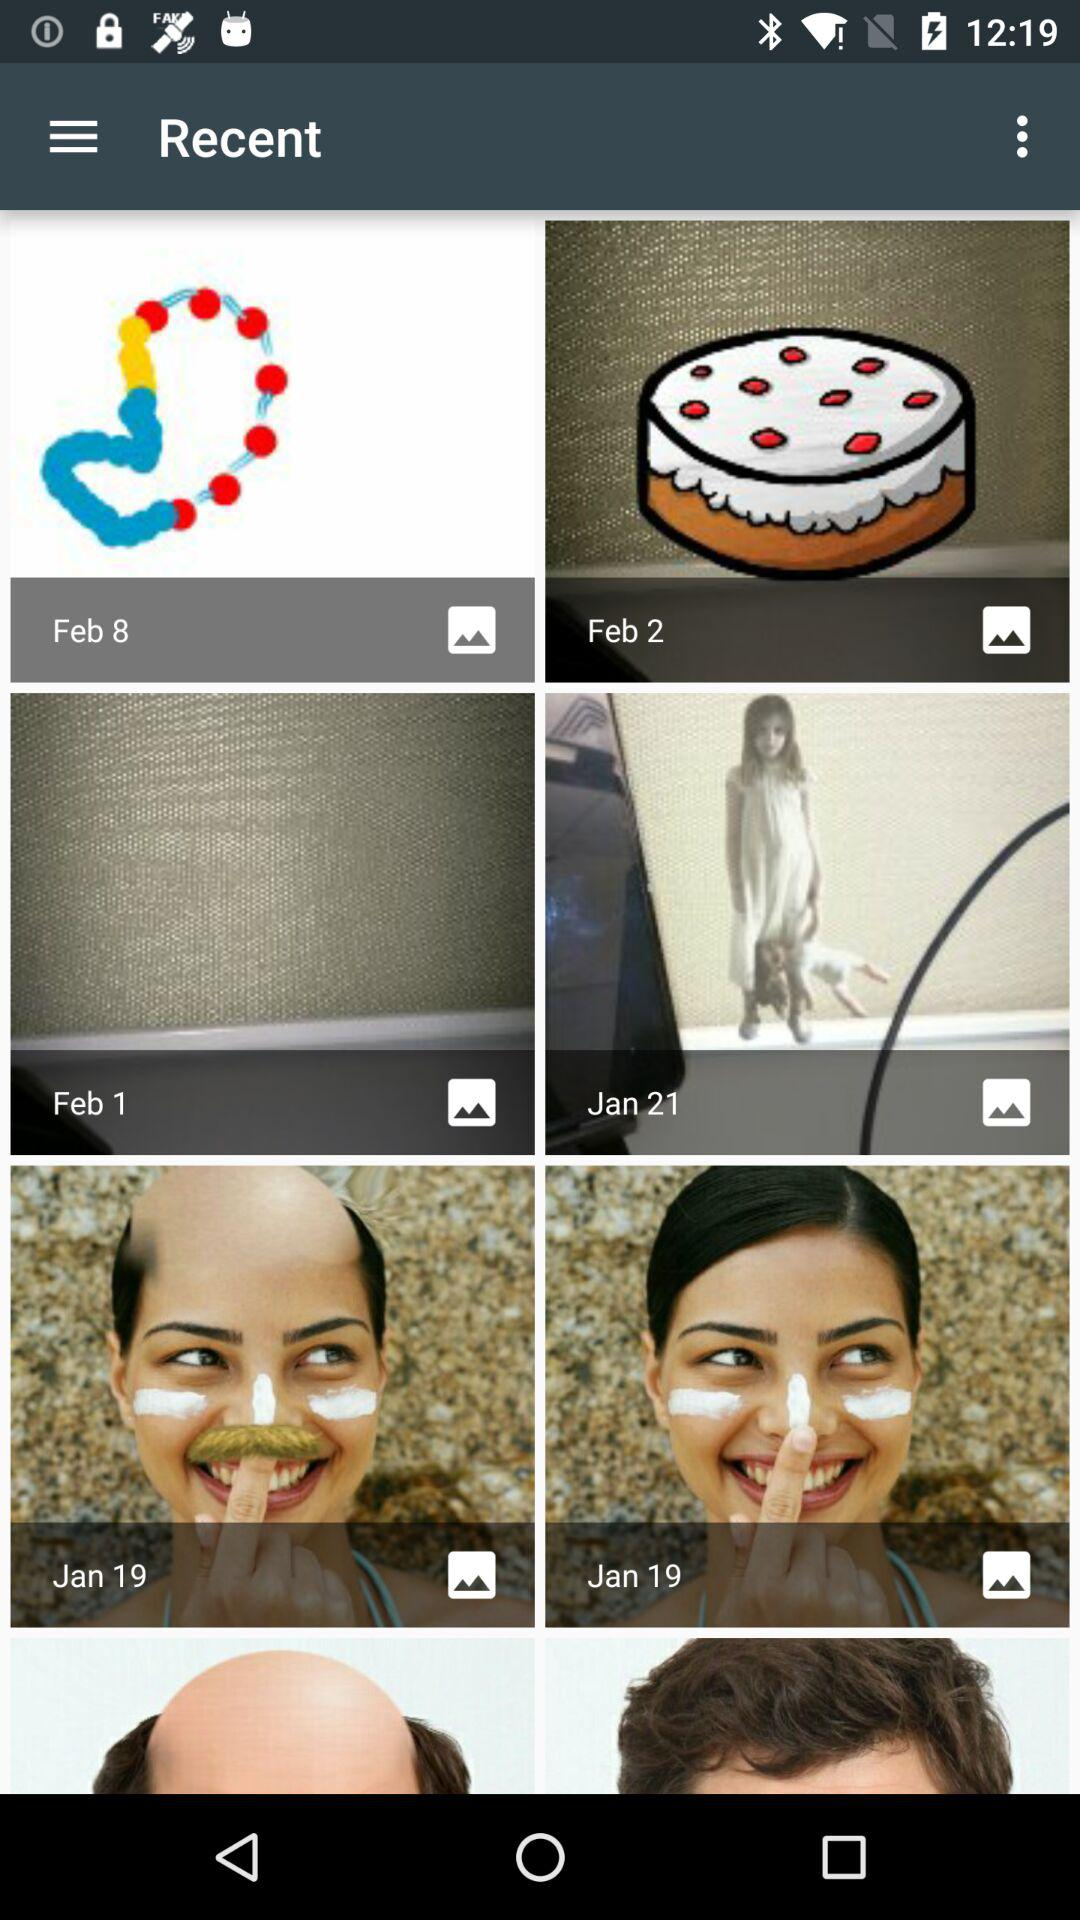How many items are in the gallery?
Answer the question using a single word or phrase. 8 